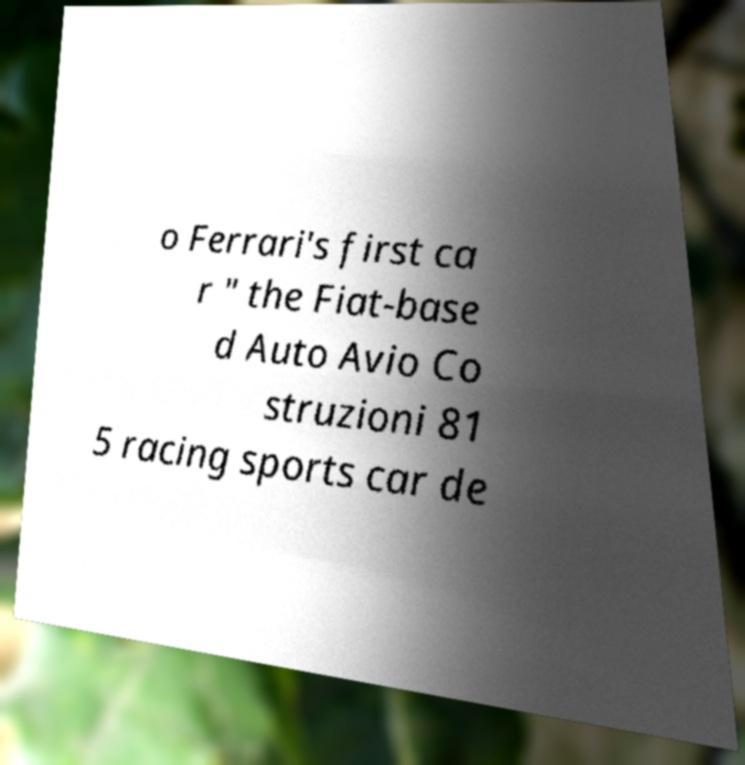For documentation purposes, I need the text within this image transcribed. Could you provide that? o Ferrari's first ca r " the Fiat-base d Auto Avio Co struzioni 81 5 racing sports car de 